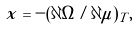Convert formula to latex. <formula><loc_0><loc_0><loc_500><loc_500>x = - ( \partial \Omega / \partial \mu ) _ { T } ,</formula> 